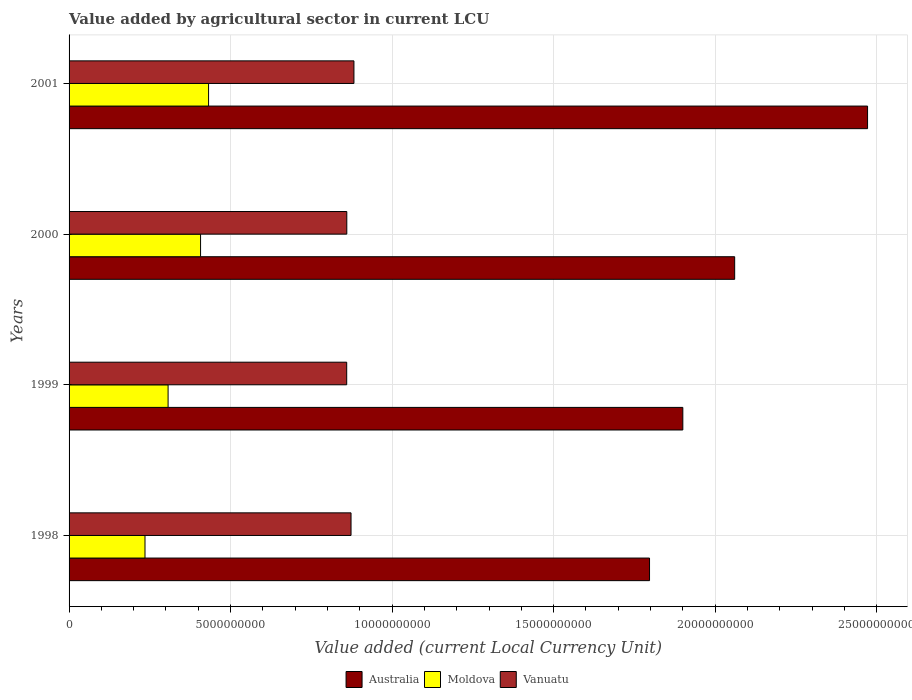How many different coloured bars are there?
Your answer should be compact. 3. How many groups of bars are there?
Keep it short and to the point. 4. Are the number of bars on each tick of the Y-axis equal?
Keep it short and to the point. Yes. How many bars are there on the 4th tick from the bottom?
Keep it short and to the point. 3. What is the label of the 2nd group of bars from the top?
Provide a succinct answer. 2000. In how many cases, is the number of bars for a given year not equal to the number of legend labels?
Ensure brevity in your answer.  0. What is the value added by agricultural sector in Moldova in 1999?
Your response must be concise. 3.07e+09. Across all years, what is the maximum value added by agricultural sector in Vanuatu?
Keep it short and to the point. 8.82e+09. Across all years, what is the minimum value added by agricultural sector in Moldova?
Keep it short and to the point. 2.35e+09. In which year was the value added by agricultural sector in Vanuatu maximum?
Your answer should be compact. 2001. What is the total value added by agricultural sector in Vanuatu in the graph?
Offer a terse response. 3.47e+1. What is the difference between the value added by agricultural sector in Vanuatu in 1999 and that in 2000?
Your answer should be very brief. -3.00e+06. What is the difference between the value added by agricultural sector in Moldova in 2000 and the value added by agricultural sector in Vanuatu in 1999?
Offer a very short reply. -4.52e+09. What is the average value added by agricultural sector in Australia per year?
Give a very brief answer. 2.06e+1. In the year 2001, what is the difference between the value added by agricultural sector in Moldova and value added by agricultural sector in Australia?
Provide a succinct answer. -2.04e+1. In how many years, is the value added by agricultural sector in Moldova greater than 21000000000 LCU?
Keep it short and to the point. 0. What is the ratio of the value added by agricultural sector in Australia in 1999 to that in 2001?
Your answer should be compact. 0.77. What is the difference between the highest and the second highest value added by agricultural sector in Moldova?
Your answer should be compact. 2.48e+08. What is the difference between the highest and the lowest value added by agricultural sector in Moldova?
Offer a terse response. 1.97e+09. In how many years, is the value added by agricultural sector in Moldova greater than the average value added by agricultural sector in Moldova taken over all years?
Provide a succinct answer. 2. What does the 3rd bar from the top in 2001 represents?
Give a very brief answer. Australia. What does the 1st bar from the bottom in 2000 represents?
Keep it short and to the point. Australia. Is it the case that in every year, the sum of the value added by agricultural sector in Vanuatu and value added by agricultural sector in Australia is greater than the value added by agricultural sector in Moldova?
Your answer should be very brief. Yes. Are the values on the major ticks of X-axis written in scientific E-notation?
Your answer should be very brief. No. Where does the legend appear in the graph?
Keep it short and to the point. Bottom center. How are the legend labels stacked?
Your response must be concise. Horizontal. What is the title of the graph?
Your answer should be compact. Value added by agricultural sector in current LCU. What is the label or title of the X-axis?
Provide a succinct answer. Value added (current Local Currency Unit). What is the Value added (current Local Currency Unit) in Australia in 1998?
Keep it short and to the point. 1.80e+1. What is the Value added (current Local Currency Unit) of Moldova in 1998?
Your answer should be very brief. 2.35e+09. What is the Value added (current Local Currency Unit) in Vanuatu in 1998?
Offer a very short reply. 8.73e+09. What is the Value added (current Local Currency Unit) in Australia in 1999?
Your response must be concise. 1.90e+1. What is the Value added (current Local Currency Unit) in Moldova in 1999?
Offer a terse response. 3.07e+09. What is the Value added (current Local Currency Unit) of Vanuatu in 1999?
Your answer should be compact. 8.60e+09. What is the Value added (current Local Currency Unit) in Australia in 2000?
Offer a terse response. 2.06e+1. What is the Value added (current Local Currency Unit) in Moldova in 2000?
Your response must be concise. 4.07e+09. What is the Value added (current Local Currency Unit) in Vanuatu in 2000?
Give a very brief answer. 8.60e+09. What is the Value added (current Local Currency Unit) in Australia in 2001?
Give a very brief answer. 2.47e+1. What is the Value added (current Local Currency Unit) in Moldova in 2001?
Your answer should be compact. 4.32e+09. What is the Value added (current Local Currency Unit) of Vanuatu in 2001?
Give a very brief answer. 8.82e+09. Across all years, what is the maximum Value added (current Local Currency Unit) in Australia?
Your answer should be very brief. 2.47e+1. Across all years, what is the maximum Value added (current Local Currency Unit) in Moldova?
Make the answer very short. 4.32e+09. Across all years, what is the maximum Value added (current Local Currency Unit) in Vanuatu?
Provide a succinct answer. 8.82e+09. Across all years, what is the minimum Value added (current Local Currency Unit) in Australia?
Make the answer very short. 1.80e+1. Across all years, what is the minimum Value added (current Local Currency Unit) in Moldova?
Provide a short and direct response. 2.35e+09. Across all years, what is the minimum Value added (current Local Currency Unit) of Vanuatu?
Ensure brevity in your answer.  8.60e+09. What is the total Value added (current Local Currency Unit) of Australia in the graph?
Offer a very short reply. 8.23e+1. What is the total Value added (current Local Currency Unit) of Moldova in the graph?
Your response must be concise. 1.38e+1. What is the total Value added (current Local Currency Unit) of Vanuatu in the graph?
Offer a terse response. 3.47e+1. What is the difference between the Value added (current Local Currency Unit) of Australia in 1998 and that in 1999?
Give a very brief answer. -1.03e+09. What is the difference between the Value added (current Local Currency Unit) of Moldova in 1998 and that in 1999?
Ensure brevity in your answer.  -7.15e+08. What is the difference between the Value added (current Local Currency Unit) in Vanuatu in 1998 and that in 1999?
Your response must be concise. 1.34e+08. What is the difference between the Value added (current Local Currency Unit) in Australia in 1998 and that in 2000?
Provide a succinct answer. -2.64e+09. What is the difference between the Value added (current Local Currency Unit) in Moldova in 1998 and that in 2000?
Provide a succinct answer. -1.72e+09. What is the difference between the Value added (current Local Currency Unit) of Vanuatu in 1998 and that in 2000?
Provide a succinct answer. 1.31e+08. What is the difference between the Value added (current Local Currency Unit) of Australia in 1998 and that in 2001?
Your response must be concise. -6.75e+09. What is the difference between the Value added (current Local Currency Unit) in Moldova in 1998 and that in 2001?
Make the answer very short. -1.97e+09. What is the difference between the Value added (current Local Currency Unit) of Vanuatu in 1998 and that in 2001?
Keep it short and to the point. -9.00e+07. What is the difference between the Value added (current Local Currency Unit) in Australia in 1999 and that in 2000?
Your answer should be very brief. -1.60e+09. What is the difference between the Value added (current Local Currency Unit) of Moldova in 1999 and that in 2000?
Keep it short and to the point. -1.00e+09. What is the difference between the Value added (current Local Currency Unit) of Vanuatu in 1999 and that in 2000?
Make the answer very short. -3.00e+06. What is the difference between the Value added (current Local Currency Unit) of Australia in 1999 and that in 2001?
Your answer should be compact. -5.72e+09. What is the difference between the Value added (current Local Currency Unit) in Moldova in 1999 and that in 2001?
Offer a very short reply. -1.25e+09. What is the difference between the Value added (current Local Currency Unit) in Vanuatu in 1999 and that in 2001?
Offer a terse response. -2.24e+08. What is the difference between the Value added (current Local Currency Unit) in Australia in 2000 and that in 2001?
Provide a succinct answer. -4.11e+09. What is the difference between the Value added (current Local Currency Unit) in Moldova in 2000 and that in 2001?
Your response must be concise. -2.48e+08. What is the difference between the Value added (current Local Currency Unit) in Vanuatu in 2000 and that in 2001?
Offer a very short reply. -2.21e+08. What is the difference between the Value added (current Local Currency Unit) in Australia in 1998 and the Value added (current Local Currency Unit) in Moldova in 1999?
Make the answer very short. 1.49e+1. What is the difference between the Value added (current Local Currency Unit) in Australia in 1998 and the Value added (current Local Currency Unit) in Vanuatu in 1999?
Offer a very short reply. 9.38e+09. What is the difference between the Value added (current Local Currency Unit) in Moldova in 1998 and the Value added (current Local Currency Unit) in Vanuatu in 1999?
Provide a short and direct response. -6.24e+09. What is the difference between the Value added (current Local Currency Unit) in Australia in 1998 and the Value added (current Local Currency Unit) in Moldova in 2000?
Provide a succinct answer. 1.39e+1. What is the difference between the Value added (current Local Currency Unit) of Australia in 1998 and the Value added (current Local Currency Unit) of Vanuatu in 2000?
Keep it short and to the point. 9.37e+09. What is the difference between the Value added (current Local Currency Unit) of Moldova in 1998 and the Value added (current Local Currency Unit) of Vanuatu in 2000?
Provide a short and direct response. -6.25e+09. What is the difference between the Value added (current Local Currency Unit) in Australia in 1998 and the Value added (current Local Currency Unit) in Moldova in 2001?
Offer a terse response. 1.37e+1. What is the difference between the Value added (current Local Currency Unit) in Australia in 1998 and the Value added (current Local Currency Unit) in Vanuatu in 2001?
Provide a succinct answer. 9.15e+09. What is the difference between the Value added (current Local Currency Unit) in Moldova in 1998 and the Value added (current Local Currency Unit) in Vanuatu in 2001?
Your answer should be very brief. -6.47e+09. What is the difference between the Value added (current Local Currency Unit) in Australia in 1999 and the Value added (current Local Currency Unit) in Moldova in 2000?
Make the answer very short. 1.49e+1. What is the difference between the Value added (current Local Currency Unit) of Australia in 1999 and the Value added (current Local Currency Unit) of Vanuatu in 2000?
Ensure brevity in your answer.  1.04e+1. What is the difference between the Value added (current Local Currency Unit) of Moldova in 1999 and the Value added (current Local Currency Unit) of Vanuatu in 2000?
Give a very brief answer. -5.53e+09. What is the difference between the Value added (current Local Currency Unit) in Australia in 1999 and the Value added (current Local Currency Unit) in Moldova in 2001?
Offer a very short reply. 1.47e+1. What is the difference between the Value added (current Local Currency Unit) of Australia in 1999 and the Value added (current Local Currency Unit) of Vanuatu in 2001?
Offer a terse response. 1.02e+1. What is the difference between the Value added (current Local Currency Unit) in Moldova in 1999 and the Value added (current Local Currency Unit) in Vanuatu in 2001?
Provide a succinct answer. -5.75e+09. What is the difference between the Value added (current Local Currency Unit) of Australia in 2000 and the Value added (current Local Currency Unit) of Moldova in 2001?
Provide a succinct answer. 1.63e+1. What is the difference between the Value added (current Local Currency Unit) of Australia in 2000 and the Value added (current Local Currency Unit) of Vanuatu in 2001?
Provide a short and direct response. 1.18e+1. What is the difference between the Value added (current Local Currency Unit) in Moldova in 2000 and the Value added (current Local Currency Unit) in Vanuatu in 2001?
Your answer should be very brief. -4.75e+09. What is the average Value added (current Local Currency Unit) of Australia per year?
Keep it short and to the point. 2.06e+1. What is the average Value added (current Local Currency Unit) of Moldova per year?
Offer a very short reply. 3.45e+09. What is the average Value added (current Local Currency Unit) in Vanuatu per year?
Offer a very short reply. 8.69e+09. In the year 1998, what is the difference between the Value added (current Local Currency Unit) in Australia and Value added (current Local Currency Unit) in Moldova?
Provide a short and direct response. 1.56e+1. In the year 1998, what is the difference between the Value added (current Local Currency Unit) of Australia and Value added (current Local Currency Unit) of Vanuatu?
Offer a very short reply. 9.24e+09. In the year 1998, what is the difference between the Value added (current Local Currency Unit) in Moldova and Value added (current Local Currency Unit) in Vanuatu?
Make the answer very short. -6.38e+09. In the year 1999, what is the difference between the Value added (current Local Currency Unit) in Australia and Value added (current Local Currency Unit) in Moldova?
Keep it short and to the point. 1.59e+1. In the year 1999, what is the difference between the Value added (current Local Currency Unit) in Australia and Value added (current Local Currency Unit) in Vanuatu?
Give a very brief answer. 1.04e+1. In the year 1999, what is the difference between the Value added (current Local Currency Unit) in Moldova and Value added (current Local Currency Unit) in Vanuatu?
Make the answer very short. -5.53e+09. In the year 2000, what is the difference between the Value added (current Local Currency Unit) in Australia and Value added (current Local Currency Unit) in Moldova?
Offer a terse response. 1.65e+1. In the year 2000, what is the difference between the Value added (current Local Currency Unit) in Australia and Value added (current Local Currency Unit) in Vanuatu?
Your answer should be very brief. 1.20e+1. In the year 2000, what is the difference between the Value added (current Local Currency Unit) of Moldova and Value added (current Local Currency Unit) of Vanuatu?
Your response must be concise. -4.53e+09. In the year 2001, what is the difference between the Value added (current Local Currency Unit) of Australia and Value added (current Local Currency Unit) of Moldova?
Provide a short and direct response. 2.04e+1. In the year 2001, what is the difference between the Value added (current Local Currency Unit) of Australia and Value added (current Local Currency Unit) of Vanuatu?
Make the answer very short. 1.59e+1. In the year 2001, what is the difference between the Value added (current Local Currency Unit) in Moldova and Value added (current Local Currency Unit) in Vanuatu?
Give a very brief answer. -4.50e+09. What is the ratio of the Value added (current Local Currency Unit) of Australia in 1998 to that in 1999?
Your response must be concise. 0.95. What is the ratio of the Value added (current Local Currency Unit) in Moldova in 1998 to that in 1999?
Give a very brief answer. 0.77. What is the ratio of the Value added (current Local Currency Unit) of Vanuatu in 1998 to that in 1999?
Your answer should be very brief. 1.02. What is the ratio of the Value added (current Local Currency Unit) of Australia in 1998 to that in 2000?
Your answer should be very brief. 0.87. What is the ratio of the Value added (current Local Currency Unit) of Moldova in 1998 to that in 2000?
Provide a short and direct response. 0.58. What is the ratio of the Value added (current Local Currency Unit) of Vanuatu in 1998 to that in 2000?
Your answer should be compact. 1.02. What is the ratio of the Value added (current Local Currency Unit) in Australia in 1998 to that in 2001?
Offer a terse response. 0.73. What is the ratio of the Value added (current Local Currency Unit) in Moldova in 1998 to that in 2001?
Offer a terse response. 0.54. What is the ratio of the Value added (current Local Currency Unit) in Vanuatu in 1998 to that in 2001?
Give a very brief answer. 0.99. What is the ratio of the Value added (current Local Currency Unit) in Australia in 1999 to that in 2000?
Keep it short and to the point. 0.92. What is the ratio of the Value added (current Local Currency Unit) of Moldova in 1999 to that in 2000?
Your answer should be compact. 0.75. What is the ratio of the Value added (current Local Currency Unit) in Vanuatu in 1999 to that in 2000?
Ensure brevity in your answer.  1. What is the ratio of the Value added (current Local Currency Unit) in Australia in 1999 to that in 2001?
Your answer should be very brief. 0.77. What is the ratio of the Value added (current Local Currency Unit) in Moldova in 1999 to that in 2001?
Offer a very short reply. 0.71. What is the ratio of the Value added (current Local Currency Unit) of Vanuatu in 1999 to that in 2001?
Provide a short and direct response. 0.97. What is the ratio of the Value added (current Local Currency Unit) of Australia in 2000 to that in 2001?
Give a very brief answer. 0.83. What is the ratio of the Value added (current Local Currency Unit) of Moldova in 2000 to that in 2001?
Offer a terse response. 0.94. What is the ratio of the Value added (current Local Currency Unit) in Vanuatu in 2000 to that in 2001?
Keep it short and to the point. 0.97. What is the difference between the highest and the second highest Value added (current Local Currency Unit) of Australia?
Provide a succinct answer. 4.11e+09. What is the difference between the highest and the second highest Value added (current Local Currency Unit) in Moldova?
Offer a very short reply. 2.48e+08. What is the difference between the highest and the second highest Value added (current Local Currency Unit) of Vanuatu?
Keep it short and to the point. 9.00e+07. What is the difference between the highest and the lowest Value added (current Local Currency Unit) in Australia?
Provide a short and direct response. 6.75e+09. What is the difference between the highest and the lowest Value added (current Local Currency Unit) of Moldova?
Provide a succinct answer. 1.97e+09. What is the difference between the highest and the lowest Value added (current Local Currency Unit) of Vanuatu?
Ensure brevity in your answer.  2.24e+08. 